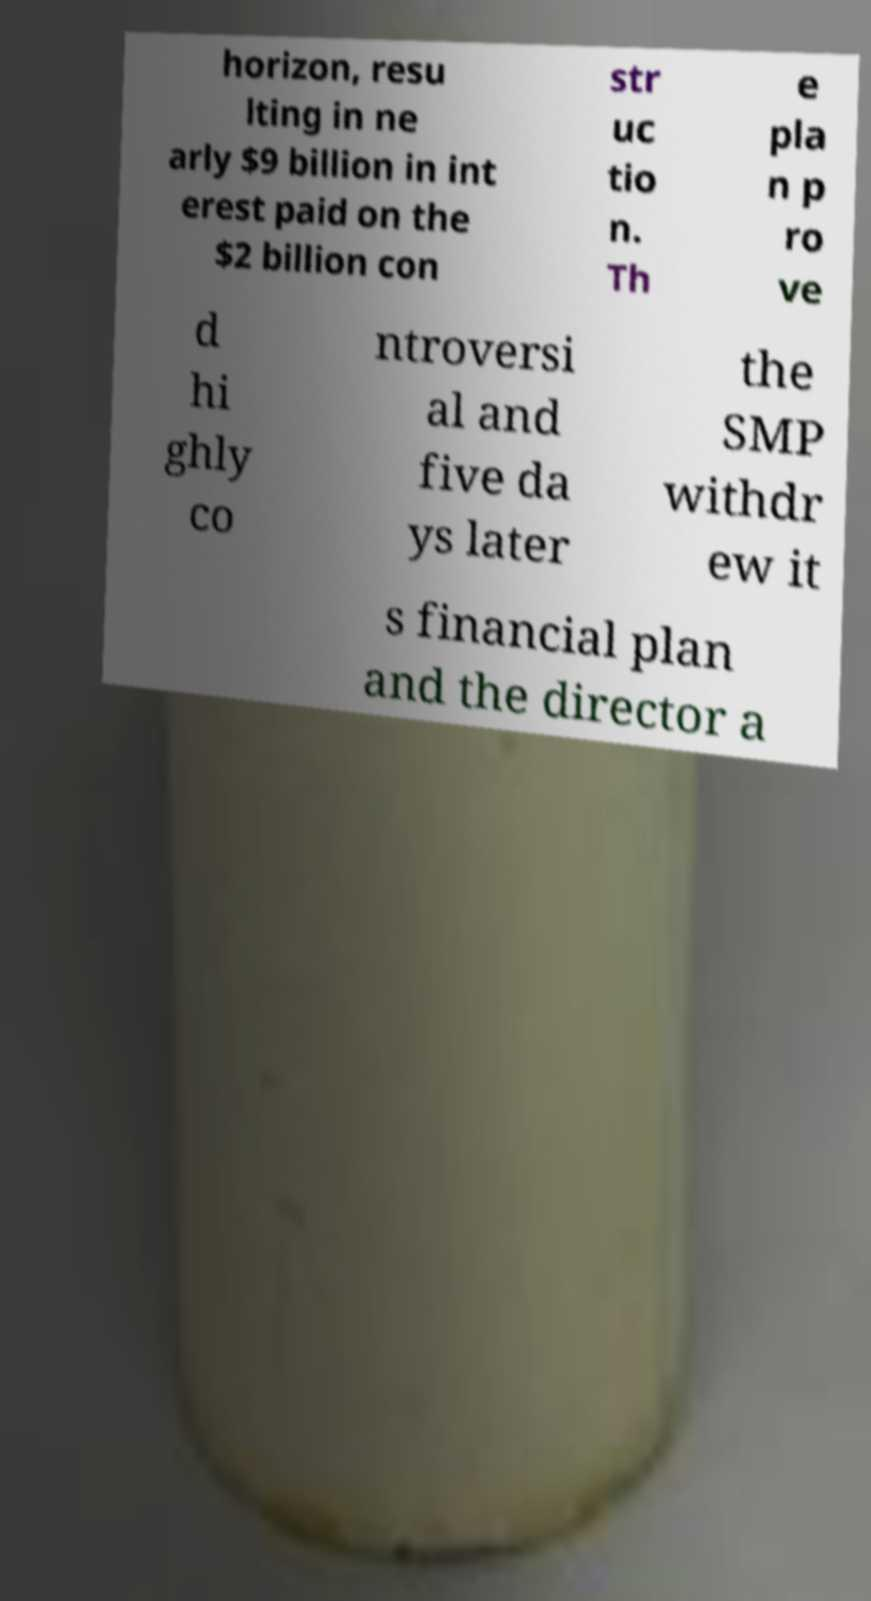Can you accurately transcribe the text from the provided image for me? horizon, resu lting in ne arly $9 billion in int erest paid on the $2 billion con str uc tio n. Th e pla n p ro ve d hi ghly co ntroversi al and five da ys later the SMP withdr ew it s financial plan and the director a 